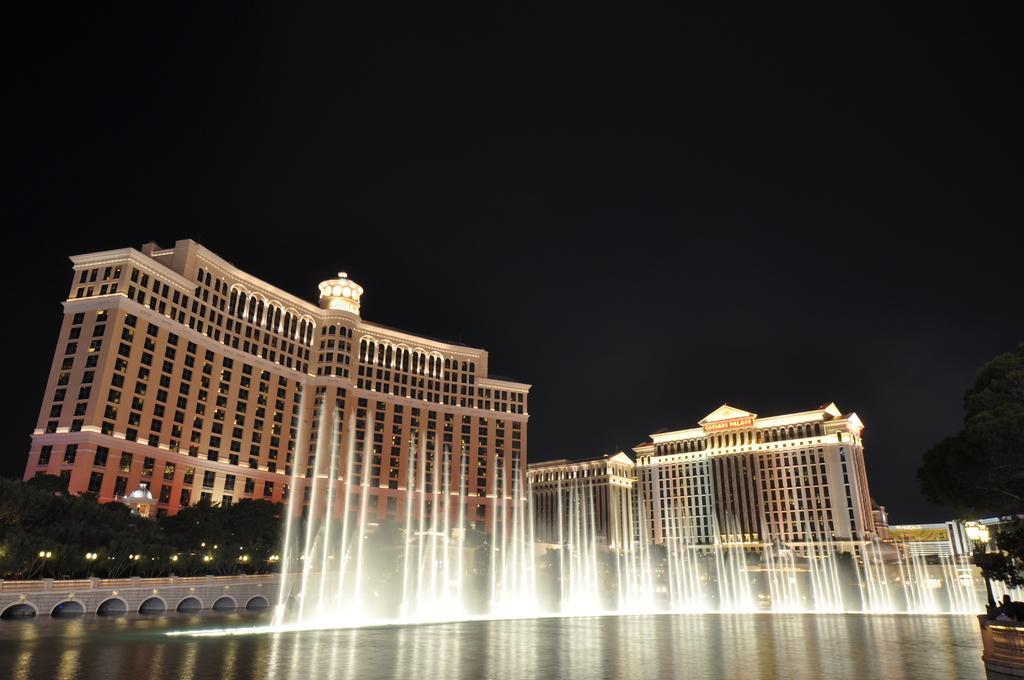Can you describe this image briefly? Here we can see water. On the background we can see buildings,trees,lights and sky. 